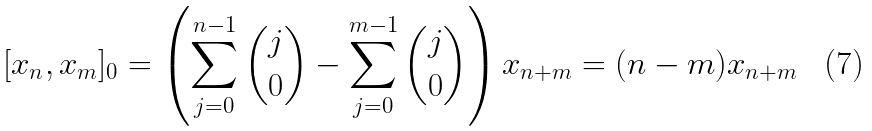<formula> <loc_0><loc_0><loc_500><loc_500>[ x _ { n } , x _ { m } ] _ { 0 } = \left ( \sum _ { j = 0 } ^ { n - 1 } \binom { j } { 0 } - \sum _ { j = 0 } ^ { m - 1 } \binom { j } { 0 } \right ) x _ { n + m } = ( n - m ) x _ { n + m }</formula> 